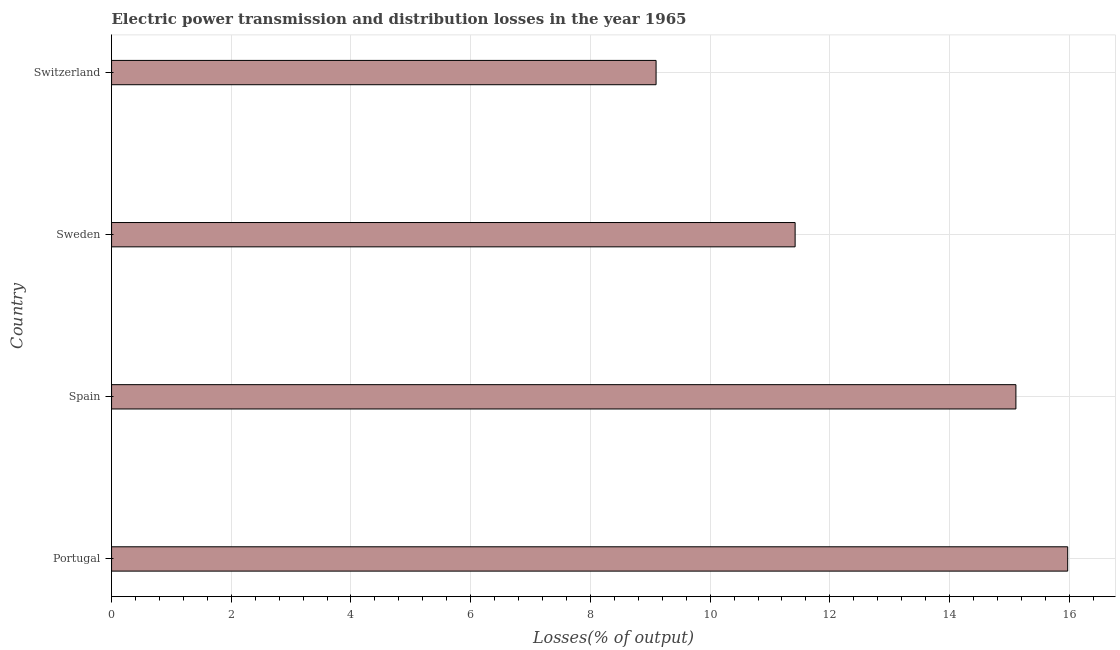Does the graph contain any zero values?
Your answer should be very brief. No. Does the graph contain grids?
Give a very brief answer. Yes. What is the title of the graph?
Provide a short and direct response. Electric power transmission and distribution losses in the year 1965. What is the label or title of the X-axis?
Provide a short and direct response. Losses(% of output). What is the electric power transmission and distribution losses in Sweden?
Your answer should be compact. 11.42. Across all countries, what is the maximum electric power transmission and distribution losses?
Give a very brief answer. 15.97. Across all countries, what is the minimum electric power transmission and distribution losses?
Your response must be concise. 9.1. In which country was the electric power transmission and distribution losses maximum?
Offer a very short reply. Portugal. In which country was the electric power transmission and distribution losses minimum?
Provide a succinct answer. Switzerland. What is the sum of the electric power transmission and distribution losses?
Provide a succinct answer. 51.6. What is the difference between the electric power transmission and distribution losses in Portugal and Spain?
Give a very brief answer. 0.86. What is the median electric power transmission and distribution losses?
Offer a terse response. 13.26. In how many countries, is the electric power transmission and distribution losses greater than 15.2 %?
Ensure brevity in your answer.  1. What is the ratio of the electric power transmission and distribution losses in Spain to that in Sweden?
Your answer should be compact. 1.32. Is the difference between the electric power transmission and distribution losses in Spain and Switzerland greater than the difference between any two countries?
Your answer should be compact. No. What is the difference between the highest and the second highest electric power transmission and distribution losses?
Keep it short and to the point. 0.86. Is the sum of the electric power transmission and distribution losses in Spain and Switzerland greater than the maximum electric power transmission and distribution losses across all countries?
Ensure brevity in your answer.  Yes. What is the difference between the highest and the lowest electric power transmission and distribution losses?
Your answer should be very brief. 6.88. In how many countries, is the electric power transmission and distribution losses greater than the average electric power transmission and distribution losses taken over all countries?
Make the answer very short. 2. How many countries are there in the graph?
Your answer should be compact. 4. What is the Losses(% of output) in Portugal?
Provide a short and direct response. 15.97. What is the Losses(% of output) in Spain?
Offer a very short reply. 15.11. What is the Losses(% of output) in Sweden?
Ensure brevity in your answer.  11.42. What is the Losses(% of output) of Switzerland?
Offer a terse response. 9.1. What is the difference between the Losses(% of output) in Portugal and Spain?
Provide a short and direct response. 0.86. What is the difference between the Losses(% of output) in Portugal and Sweden?
Offer a terse response. 4.55. What is the difference between the Losses(% of output) in Portugal and Switzerland?
Keep it short and to the point. 6.88. What is the difference between the Losses(% of output) in Spain and Sweden?
Offer a very short reply. 3.69. What is the difference between the Losses(% of output) in Spain and Switzerland?
Ensure brevity in your answer.  6.01. What is the difference between the Losses(% of output) in Sweden and Switzerland?
Keep it short and to the point. 2.32. What is the ratio of the Losses(% of output) in Portugal to that in Spain?
Your answer should be very brief. 1.06. What is the ratio of the Losses(% of output) in Portugal to that in Sweden?
Provide a succinct answer. 1.4. What is the ratio of the Losses(% of output) in Portugal to that in Switzerland?
Your response must be concise. 1.76. What is the ratio of the Losses(% of output) in Spain to that in Sweden?
Offer a very short reply. 1.32. What is the ratio of the Losses(% of output) in Spain to that in Switzerland?
Offer a terse response. 1.66. What is the ratio of the Losses(% of output) in Sweden to that in Switzerland?
Provide a short and direct response. 1.25. 